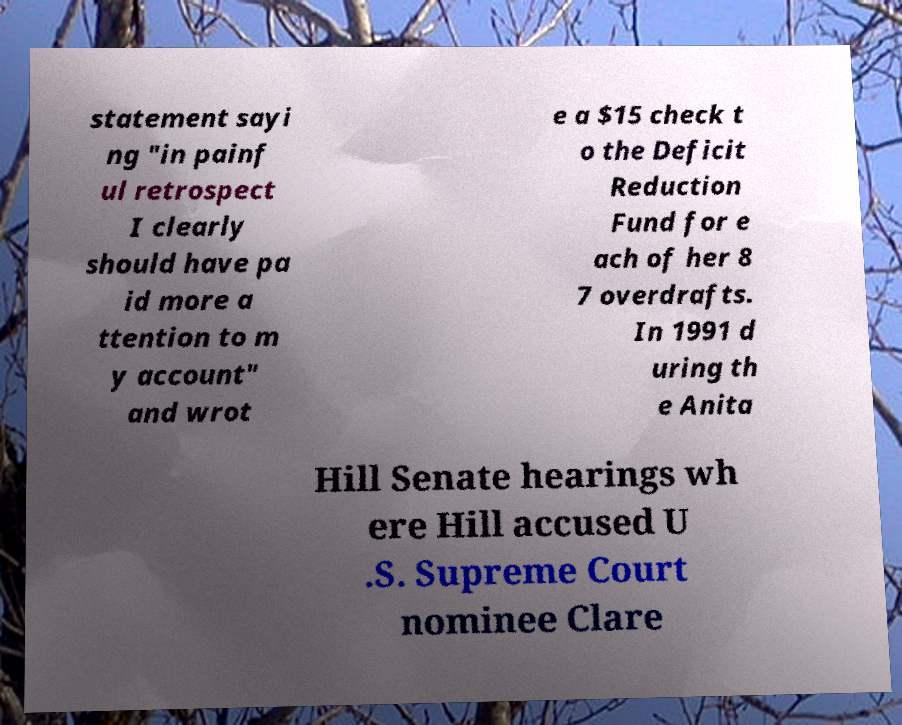Can you read and provide the text displayed in the image?This photo seems to have some interesting text. Can you extract and type it out for me? statement sayi ng "in painf ul retrospect I clearly should have pa id more a ttention to m y account" and wrot e a $15 check t o the Deficit Reduction Fund for e ach of her 8 7 overdrafts. In 1991 d uring th e Anita Hill Senate hearings wh ere Hill accused U .S. Supreme Court nominee Clare 